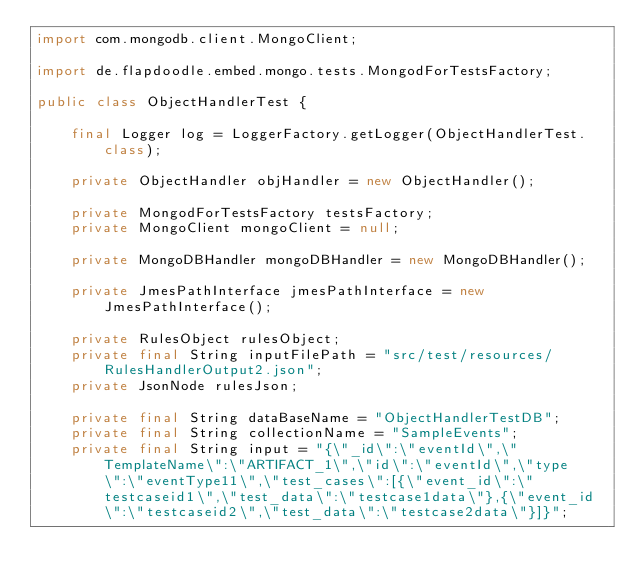<code> <loc_0><loc_0><loc_500><loc_500><_Java_>import com.mongodb.client.MongoClient;

import de.flapdoodle.embed.mongo.tests.MongodForTestsFactory;

public class ObjectHandlerTest {

    final Logger log = LoggerFactory.getLogger(ObjectHandlerTest.class);

    private ObjectHandler objHandler = new ObjectHandler();

    private MongodForTestsFactory testsFactory;
    private MongoClient mongoClient = null;

    private MongoDBHandler mongoDBHandler = new MongoDBHandler();

    private JmesPathInterface jmesPathInterface = new JmesPathInterface();

    private RulesObject rulesObject;
    private final String inputFilePath = "src/test/resources/RulesHandlerOutput2.json";
    private JsonNode rulesJson;

    private final String dataBaseName = "ObjectHandlerTestDB";
    private final String collectionName = "SampleEvents";
    private final String input = "{\"_id\":\"eventId\",\"TemplateName\":\"ARTIFACT_1\",\"id\":\"eventId\",\"type\":\"eventType11\",\"test_cases\":[{\"event_id\":\"testcaseid1\",\"test_data\":\"testcase1data\"},{\"event_id\":\"testcaseid2\",\"test_data\":\"testcase2data\"}]}";</code> 